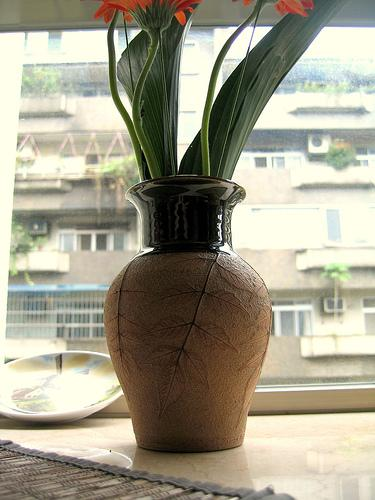Enumerate three main objects in the image. A flower-filled vase, a decorative plate, and a bamboo mat. What emotion does the image evoke, and why? The image evokes a sense of calm and tranquility, due to the serene arrangement of flowers, decorative plate, and nature visible through the window. What is the pattern on the flower vase? The vase has a black and brown color with leaf patterns. Identify one unique feature of the vase. The vase has leaf imprints on its surface. What is the vase placed upon in the image? The vase is placed upon a bamboo mat with brown trim on a light brown marble countertop. How many total objects are in the scene, including the vase, flowers, mat, and plate? There are four main objects: the vase, flowers, mat, and plate. Provide a brief summary of the image. A decorative vase with orange flowers sits on a bamboo mat, near a plate leaning against a window, on a light brown marble countertop. Balconies and an air conditioning unit can be seen through the window. Describe the setting outside the window. Outside the window, there are plants on balconies, an air conditioner unit, a small palm tree, and a metal fence. What color are the flowers inside the vase? The flowers are orange with green stems. What type of plate is visible in the image and where is it located? A decorative plate leaning against the window is present in the image. Which part of the flower inside the vase is orange colored? Blooms Can you describe the vase on the countertop in two colors? Black and brown Explain the interaction between the vase and the flowers. Orange flowers are inside the decorative vase Can you find any objects leaning or hanging at the window? Describe them. Decorative plate leaning against the window and hanging basket with orange flowers on the right. Describe the plant near the window and its location. A small skinny palm tree is located at the right side. Describe the balcony in the scene. A 2nd story balcony with metal grill and a plant on it Find an object that can be used on a table as a decorative item. A pretty bowl plate Which object can be found on the bottom right part of the apartment building? Air conditioning unit Identify the object on the bottom right corner of the apartment building. air conditioning unit What color is the stem of the flowers in the vase? Green Which objects are interacting at the window? decorative plate is leaning against the window What type of patterns exist on the vase on the table? Leaf patterns What are the main components in the scene that involve flowers? a) Decorative plate and bamboo mat Can you find any orange-colored items in this image? Orange flowers in a vase and orange flowers in a hanging basket What kind of tree can you observe outside of the window? Palm tree Describe the items placed on the mat in the center of the image. Vase with orange flowers and a decorative plate Which objects can you see near the window air conditioning unit? Double glass porch doors and a small skinny palm tree Which items in the scene are placed on the bamboo mat? Black and brown vase with orange flowers and a decorative plate leaning against the window 